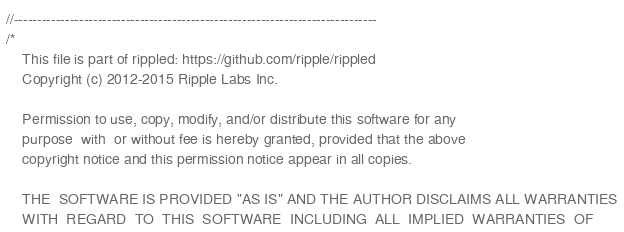<code> <loc_0><loc_0><loc_500><loc_500><_C++_>//------------------------------------------------------------------------------
/*
    This file is part of rippled: https://github.com/ripple/rippled
    Copyright (c) 2012-2015 Ripple Labs Inc.

    Permission to use, copy, modify, and/or distribute this software for any
    purpose  with  or without fee is hereby granted, provided that the above
    copyright notice and this permission notice appear in all copies.

    THE  SOFTWARE IS PROVIDED "AS IS" AND THE AUTHOR DISCLAIMS ALL WARRANTIES
    WITH  REGARD  TO  THIS  SOFTWARE  INCLUDING  ALL  IMPLIED  WARRANTIES  OF</code> 